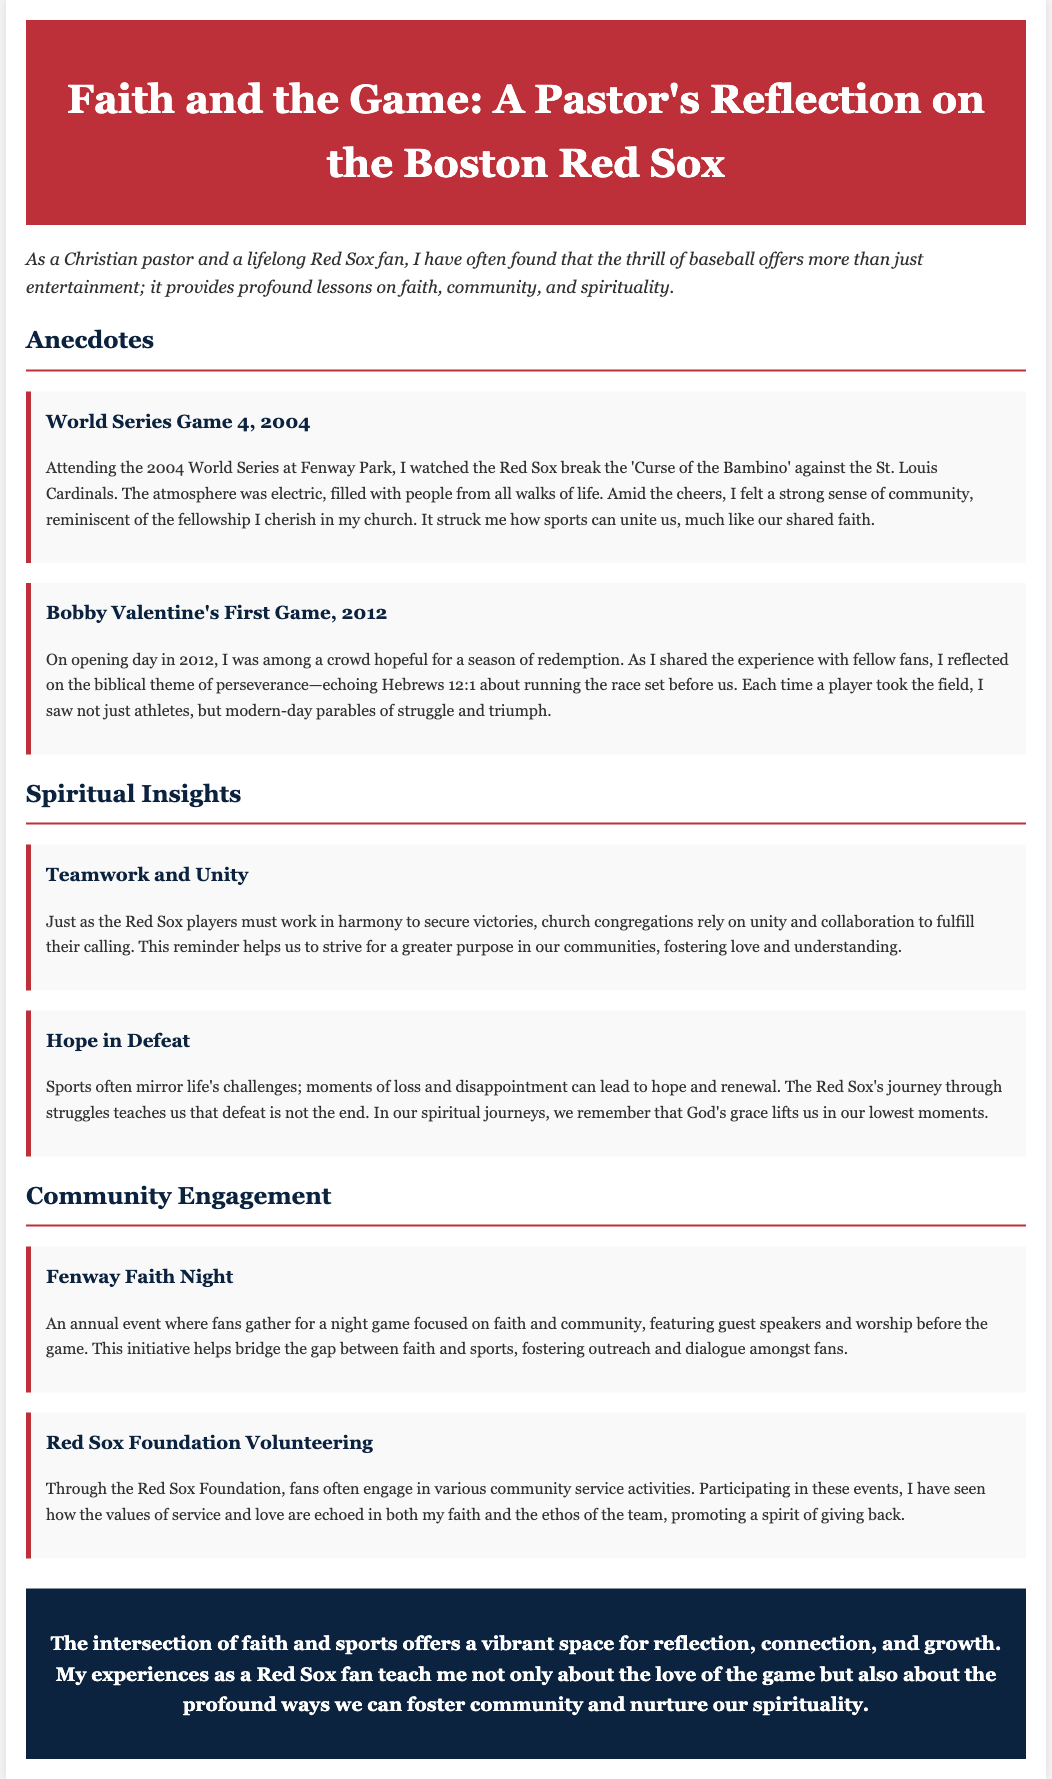What is the title of the document? The title of the document is mentioned at the top as “Faith and the Game: A Pastor's Reflection on the Boston Red Sox.”
Answer: Faith and the Game: A Pastor's Reflection on the Boston Red Sox Who did the Red Sox face in the 2004 World Series? The document states that the Red Sox faced the St. Louis Cardinals in the 2004 World Series.
Answer: St. Louis Cardinals What biblical theme is reflected during Bobby Valentine's first game? The biblical theme mentioned in relation to Bobby Valentine's first game is perseverance, as referenced in Hebrews 12:1.
Answer: Perseverance What annual event is focused on faith and community at Fenway Park? The document describes "Fenway Faith Night" as an annual event that focuses on faith and community.
Answer: Fenway Faith Night What does the author suggest about teamwork in relation to church unity? The document suggests that just as teamwork is essential for the Red Sox, unity and collaboration are also essential for church congregations.
Answer: Unity and collaboration How does the author view moments of loss in sports? The author views moments of loss in sports as opportunities for hope and renewal, teaching that defeat is not the end.
Answer: Hope and renewal Which organization offers volunteering opportunities for fans? The Red Sox Foundation provides opportunities for fans to engage in community service.
Answer: Red Sox Foundation What feeling does the author experience during the 2004 World Series? The author experiences a strong sense of community during the atmosphere of the 2004 World Series at Fenway Park.
Answer: Strong sense of community 